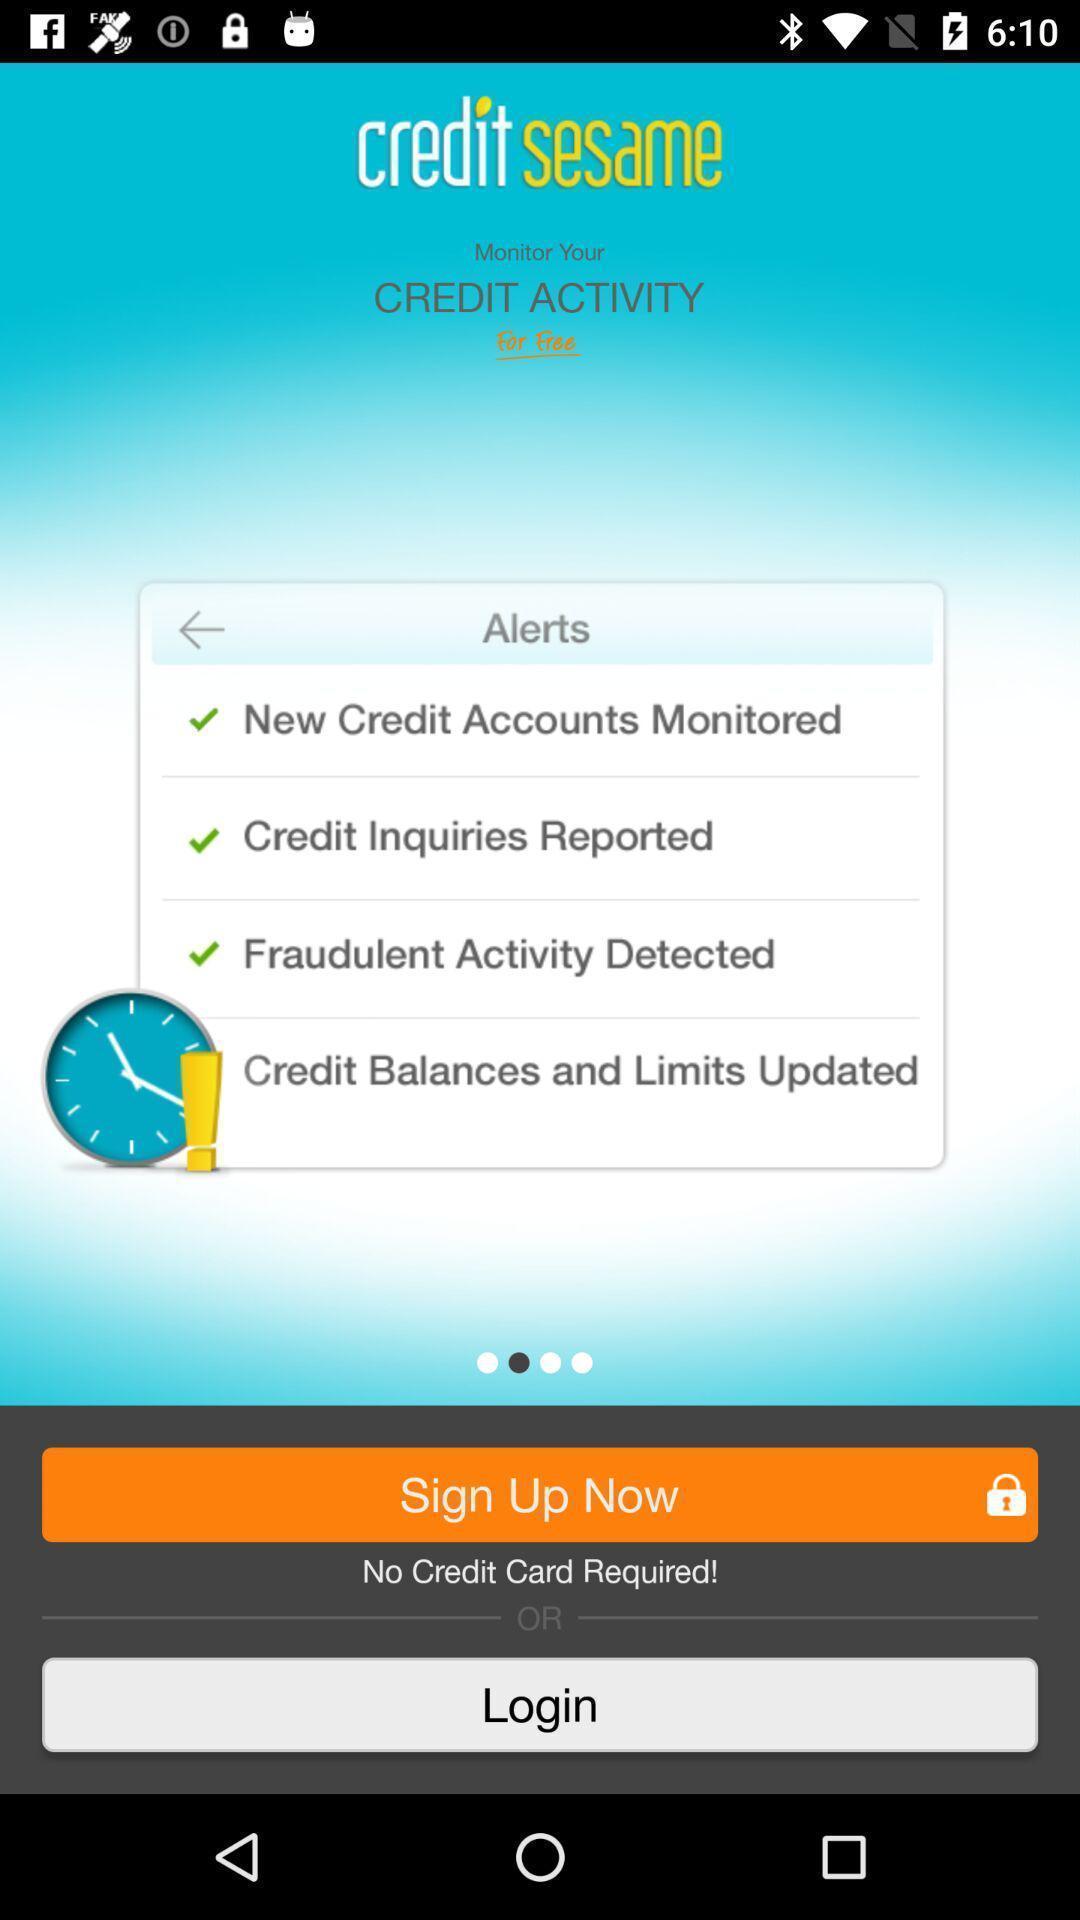Explain the elements present in this screenshot. Sign up page. 